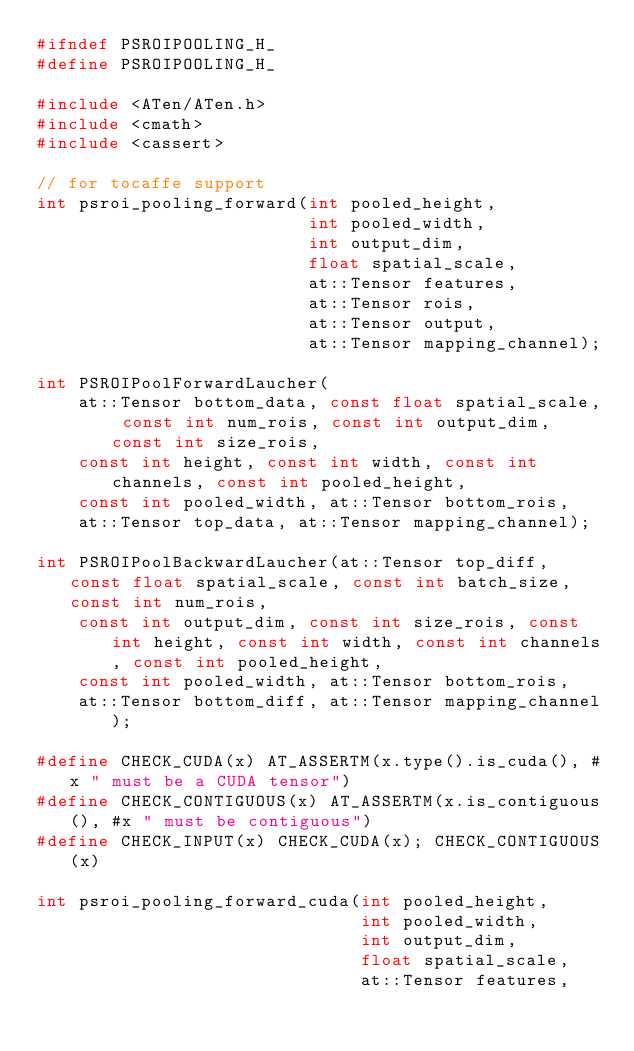<code> <loc_0><loc_0><loc_500><loc_500><_C_>#ifndef PSROIPOOLING_H_
#define PSROIPOOLING_H_

#include <ATen/ATen.h>
#include <cmath>
#include <cassert>

// for tocaffe support
int psroi_pooling_forward(int pooled_height,
                          int pooled_width,
                          int output_dim,
                          float spatial_scale,
                          at::Tensor features,
                          at::Tensor rois,
                          at::Tensor output,
                          at::Tensor mapping_channel);

int PSROIPoolForwardLaucher(
    at::Tensor bottom_data, const float spatial_scale, const int num_rois, const int output_dim, const int size_rois,
    const int height, const int width, const int channels, const int pooled_height,
    const int pooled_width, at::Tensor bottom_rois,
    at::Tensor top_data, at::Tensor mapping_channel);

int PSROIPoolBackwardLaucher(at::Tensor top_diff, const float spatial_scale, const int batch_size, const int num_rois,
    const int output_dim, const int size_rois, const int height, const int width, const int channels, const int pooled_height,
    const int pooled_width, at::Tensor bottom_rois,
    at::Tensor bottom_diff, at::Tensor mapping_channel);

#define CHECK_CUDA(x) AT_ASSERTM(x.type().is_cuda(), #x " must be a CUDA tensor")
#define CHECK_CONTIGUOUS(x) AT_ASSERTM(x.is_contiguous(), #x " must be contiguous")
#define CHECK_INPUT(x) CHECK_CUDA(x); CHECK_CONTIGUOUS(x)

int psroi_pooling_forward_cuda(int pooled_height,
                               int pooled_width,
                               int output_dim,
                               float spatial_scale,
                               at::Tensor features,</code> 